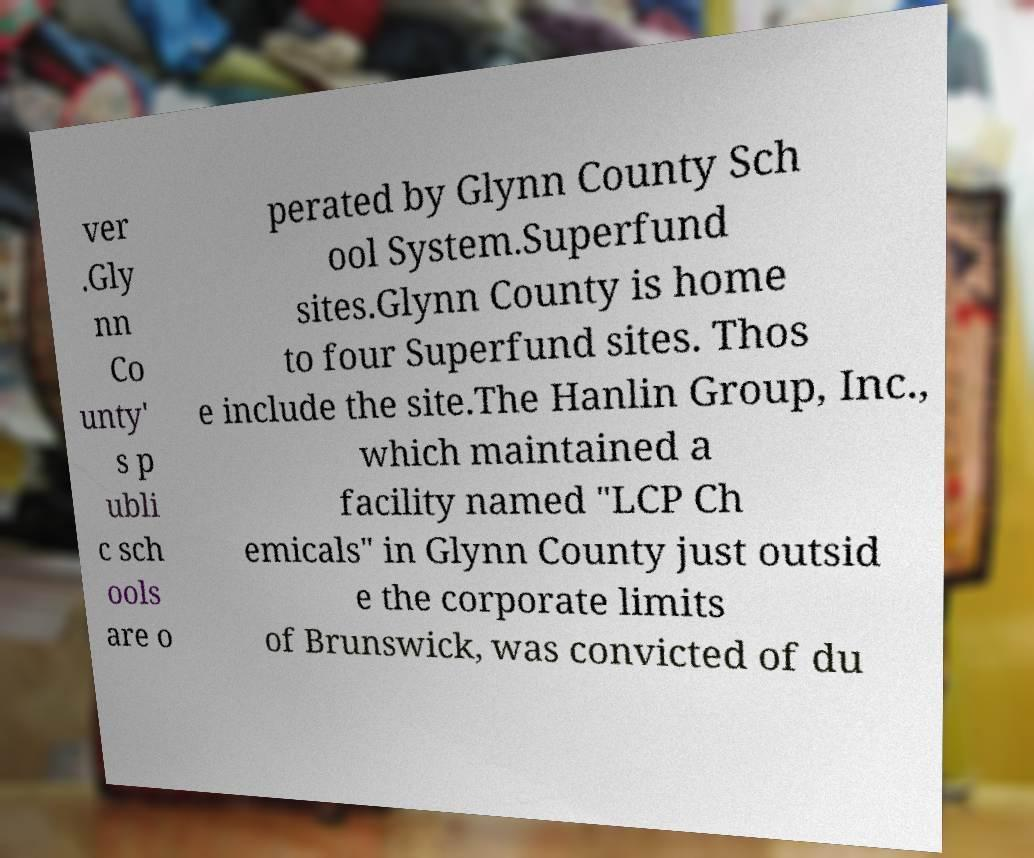Can you read and provide the text displayed in the image?This photo seems to have some interesting text. Can you extract and type it out for me? ver .Gly nn Co unty' s p ubli c sch ools are o perated by Glynn County Sch ool System.Superfund sites.Glynn County is home to four Superfund sites. Thos e include the site.The Hanlin Group, Inc., which maintained a facility named "LCP Ch emicals" in Glynn County just outsid e the corporate limits of Brunswick, was convicted of du 